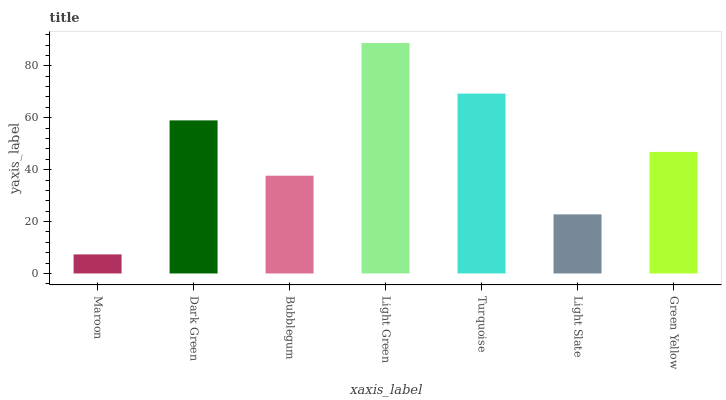Is Maroon the minimum?
Answer yes or no. Yes. Is Light Green the maximum?
Answer yes or no. Yes. Is Dark Green the minimum?
Answer yes or no. No. Is Dark Green the maximum?
Answer yes or no. No. Is Dark Green greater than Maroon?
Answer yes or no. Yes. Is Maroon less than Dark Green?
Answer yes or no. Yes. Is Maroon greater than Dark Green?
Answer yes or no. No. Is Dark Green less than Maroon?
Answer yes or no. No. Is Green Yellow the high median?
Answer yes or no. Yes. Is Green Yellow the low median?
Answer yes or no. Yes. Is Light Green the high median?
Answer yes or no. No. Is Bubblegum the low median?
Answer yes or no. No. 